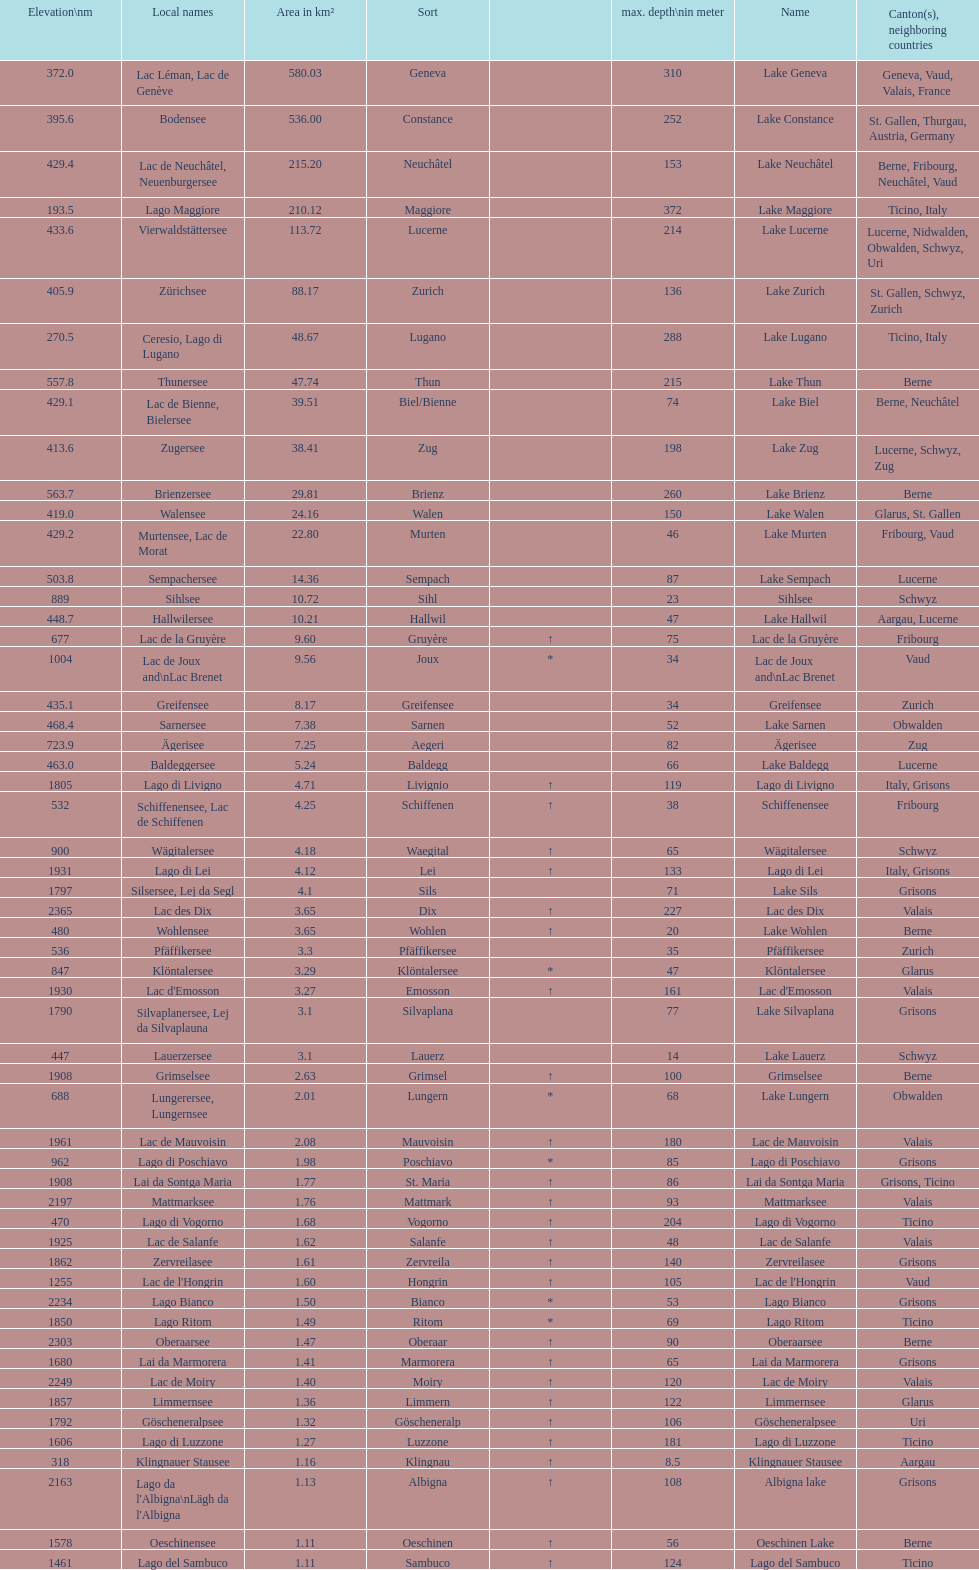Comparing albigna lake and oeschinen lake, which one has a lesser area measured in km²? Oeschinen Lake. 